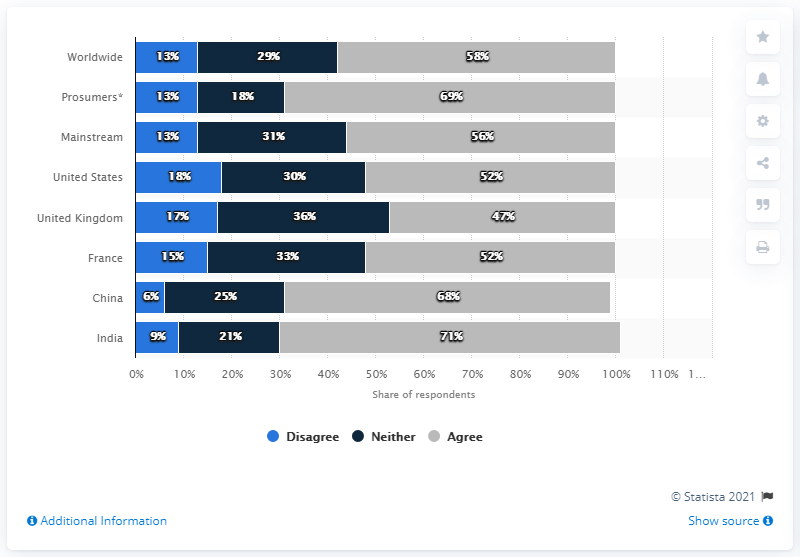Indicate a few pertinent items in this graphic. The maximum percentage of India is 71%. The use of gray color indicates agreement. 